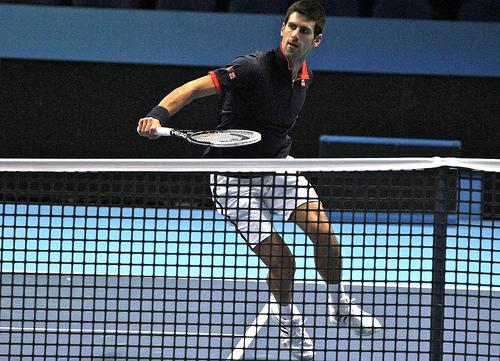Can you provide a count of the white shoes in the image? There are two white shoes in the image. What is the primary action taking place in the image involving a man? A man is playing tennis on a blue court, wearing a black shirt and white shorts, and holding a tennis racket. Mention any notable colors seen on the man in the image, specifically regarding his clothing. The man is wearing a black shirt with an orange inner collar, white shorts, and white shoes. Please describe the interaction between the man and objects in the image. The man is holding a tennis racket, ready to swing it, wearing white shoes and shorts above the knee, and standing on a blue court with a black net in the background. What is the position of the man's foot in the image? The man's foot is in the air, as he is captured mid-action while playing tennis. Provide a brief description of the tennis court. The tennis court is blue with white lines and has a black net attached to a post. How many objects are involved in the main action of the image? Three objects are involved in the main action: the man, the tennis racket, and the tennis court. What kind of sentiment does this image evoke? The image evokes a sporty and energetic sentiment, as the man is playing tennis. Explain briefly the context of the scene involving the man and the tennis racket. The scene shows a man participating in a tennis match, holding a racket in preparation to hit the ball on a blue tennis court with a black net. Examine the quality of the image and state if it is visually appealing. The image appears to be of good quality, with clear objects and vivid colors, making it visually appealing. Describe the color and position of the tennis court lines in the image. The lines on the tennis court are white, located at the lower middle part of the image. Create a visually rich scene inspired by the image components. A determined tennis player, dressed in a black shirt with an orange collar and white shorts, skillfully prepares to strike the ball on the vibrantly blue court. List the key elements of the man's tennis outfit. black shirt, orange inner collar, white shorts, white shoes Provide a stylish description of the man's outfit on the tennis court. A fashionable tennis player dons white shorts, white shoes, an orange inner collar shirt, and accessorizes with a black shirt. Which of the following is an accurate description of the man's shoes? a) red boots b) white sneakers c) yellow sandals b) white sneakers Determine if an important event is happening in the image. Yes, a tennis match is taking place. Describe the layout of the tennis-related objects in the image. The blue tennis court has a central white line, a black net is situated near the man who holds a racket, and white shoes can be seen on the ground. Identify if there is a celebration or other significant event happening in the image. No Does the image show a man playing tennis?  Yes Create a narrative based on the man and the tennis court in the image. In the heat of a challenging match, a skillful tennis player clad in a black shirt and white shorts stands poised on the radiant blue court, ready for the next swing. Identify the activity happening in the image. A man is playing tennis. What sport is the man engaging in? Tennis Describe the tennis racket in the image. The tennis racket has a predominantly black frame and features a standard string pattern. Explain the arrangement of the tennis court components in the image. A white line divides the blue tennis court, a black net is attached to a post, and a man stands behind the net holding a racket. Write an elegant caption about the tennis player and his surroundings. An accomplished athlete, garbed in a black shirt and white attire, masterfully navigates the dazzling blue tennis court. How does the man's demeanor appear as he's holding the racket? Focused and intense What color is the player's shorts on the tennis court? white 